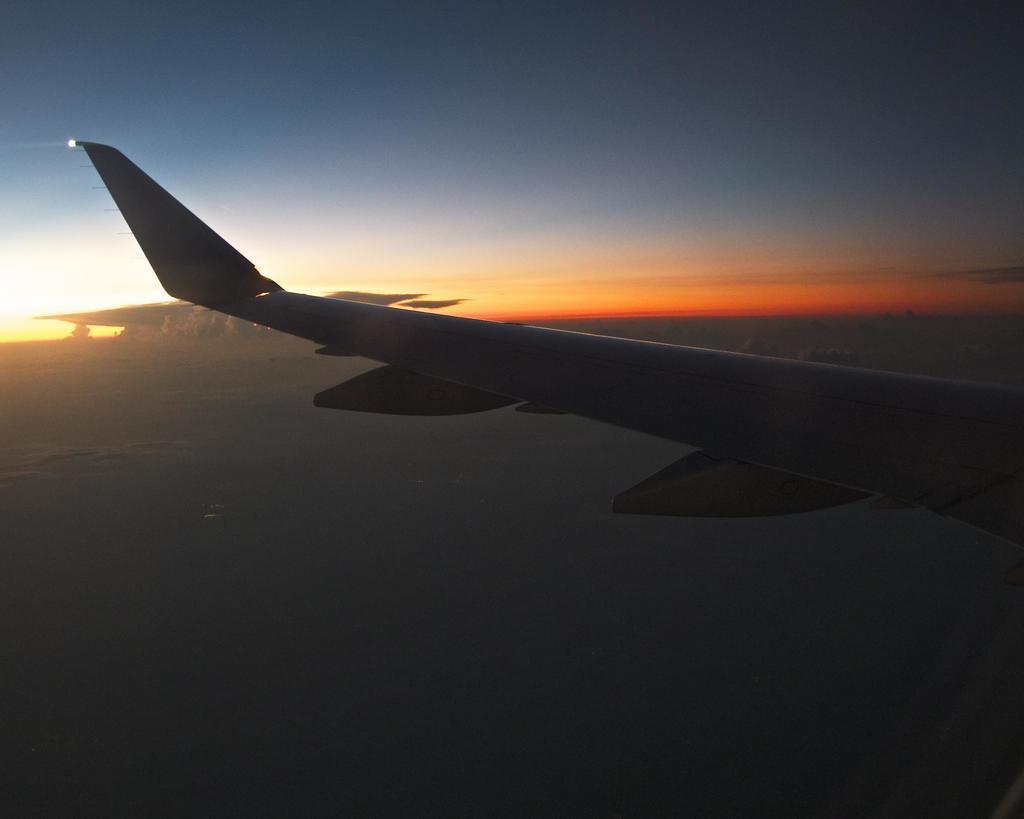Describe this image in one or two sentences. In this image we can see wing of a plane in the air. In the background we can see clouds in the sky. 